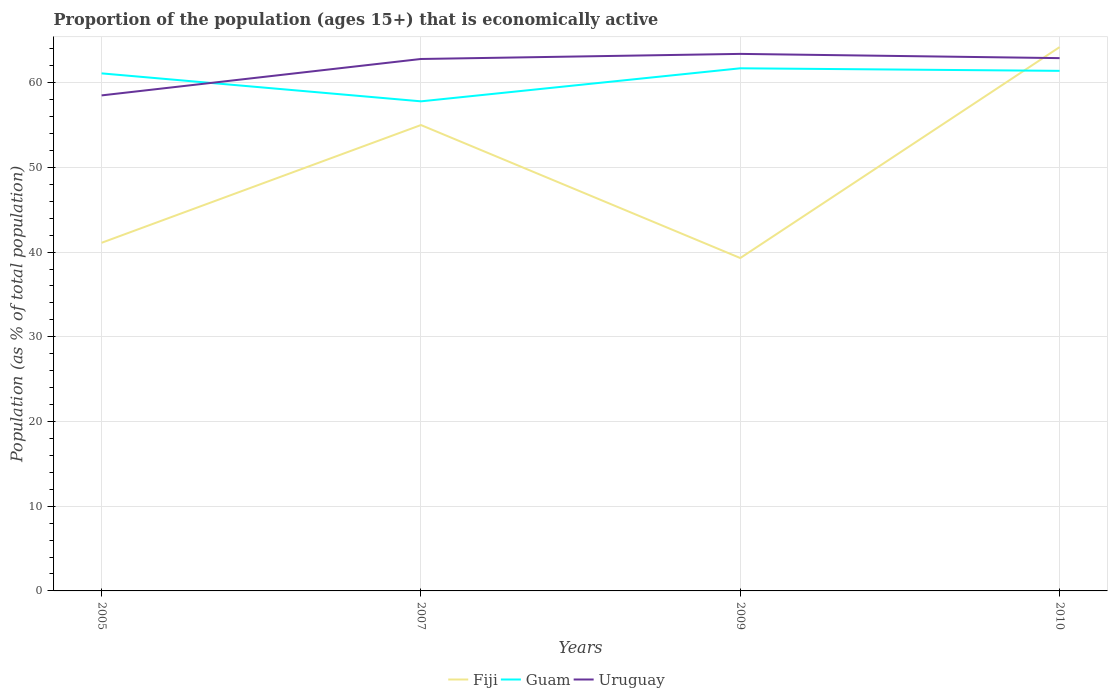Across all years, what is the maximum proportion of the population that is economically active in Fiji?
Give a very brief answer. 39.3. What is the total proportion of the population that is economically active in Uruguay in the graph?
Give a very brief answer. -0.1. What is the difference between the highest and the second highest proportion of the population that is economically active in Fiji?
Your answer should be very brief. 24.9. Are the values on the major ticks of Y-axis written in scientific E-notation?
Provide a short and direct response. No. Does the graph contain grids?
Your answer should be very brief. Yes. Where does the legend appear in the graph?
Keep it short and to the point. Bottom center. How many legend labels are there?
Provide a succinct answer. 3. What is the title of the graph?
Keep it short and to the point. Proportion of the population (ages 15+) that is economically active. Does "Guatemala" appear as one of the legend labels in the graph?
Give a very brief answer. No. What is the label or title of the Y-axis?
Give a very brief answer. Population (as % of total population). What is the Population (as % of total population) in Fiji in 2005?
Offer a terse response. 41.1. What is the Population (as % of total population) in Guam in 2005?
Make the answer very short. 61.1. What is the Population (as % of total population) in Uruguay in 2005?
Make the answer very short. 58.5. What is the Population (as % of total population) of Fiji in 2007?
Your answer should be compact. 55. What is the Population (as % of total population) of Guam in 2007?
Make the answer very short. 57.8. What is the Population (as % of total population) in Uruguay in 2007?
Your answer should be compact. 62.8. What is the Population (as % of total population) in Fiji in 2009?
Keep it short and to the point. 39.3. What is the Population (as % of total population) in Guam in 2009?
Offer a very short reply. 61.7. What is the Population (as % of total population) in Uruguay in 2009?
Ensure brevity in your answer.  63.4. What is the Population (as % of total population) in Fiji in 2010?
Provide a short and direct response. 64.2. What is the Population (as % of total population) of Guam in 2010?
Keep it short and to the point. 61.4. What is the Population (as % of total population) of Uruguay in 2010?
Give a very brief answer. 62.9. Across all years, what is the maximum Population (as % of total population) of Fiji?
Provide a succinct answer. 64.2. Across all years, what is the maximum Population (as % of total population) in Guam?
Offer a very short reply. 61.7. Across all years, what is the maximum Population (as % of total population) of Uruguay?
Keep it short and to the point. 63.4. Across all years, what is the minimum Population (as % of total population) of Fiji?
Your answer should be very brief. 39.3. Across all years, what is the minimum Population (as % of total population) of Guam?
Your response must be concise. 57.8. Across all years, what is the minimum Population (as % of total population) in Uruguay?
Offer a terse response. 58.5. What is the total Population (as % of total population) in Fiji in the graph?
Offer a terse response. 199.6. What is the total Population (as % of total population) in Guam in the graph?
Give a very brief answer. 242. What is the total Population (as % of total population) in Uruguay in the graph?
Make the answer very short. 247.6. What is the difference between the Population (as % of total population) in Uruguay in 2005 and that in 2007?
Give a very brief answer. -4.3. What is the difference between the Population (as % of total population) in Fiji in 2005 and that in 2009?
Make the answer very short. 1.8. What is the difference between the Population (as % of total population) of Uruguay in 2005 and that in 2009?
Offer a terse response. -4.9. What is the difference between the Population (as % of total population) in Fiji in 2005 and that in 2010?
Provide a short and direct response. -23.1. What is the difference between the Population (as % of total population) of Guam in 2005 and that in 2010?
Offer a terse response. -0.3. What is the difference between the Population (as % of total population) in Uruguay in 2005 and that in 2010?
Your answer should be compact. -4.4. What is the difference between the Population (as % of total population) in Fiji in 2007 and that in 2010?
Offer a terse response. -9.2. What is the difference between the Population (as % of total population) in Uruguay in 2007 and that in 2010?
Your answer should be very brief. -0.1. What is the difference between the Population (as % of total population) of Fiji in 2009 and that in 2010?
Your answer should be very brief. -24.9. What is the difference between the Population (as % of total population) in Guam in 2009 and that in 2010?
Offer a terse response. 0.3. What is the difference between the Population (as % of total population) in Uruguay in 2009 and that in 2010?
Your answer should be very brief. 0.5. What is the difference between the Population (as % of total population) in Fiji in 2005 and the Population (as % of total population) in Guam in 2007?
Your response must be concise. -16.7. What is the difference between the Population (as % of total population) in Fiji in 2005 and the Population (as % of total population) in Uruguay in 2007?
Your answer should be very brief. -21.7. What is the difference between the Population (as % of total population) in Fiji in 2005 and the Population (as % of total population) in Guam in 2009?
Make the answer very short. -20.6. What is the difference between the Population (as % of total population) of Fiji in 2005 and the Population (as % of total population) of Uruguay in 2009?
Offer a very short reply. -22.3. What is the difference between the Population (as % of total population) of Fiji in 2005 and the Population (as % of total population) of Guam in 2010?
Your answer should be very brief. -20.3. What is the difference between the Population (as % of total population) of Fiji in 2005 and the Population (as % of total population) of Uruguay in 2010?
Provide a succinct answer. -21.8. What is the difference between the Population (as % of total population) of Guam in 2005 and the Population (as % of total population) of Uruguay in 2010?
Provide a succinct answer. -1.8. What is the difference between the Population (as % of total population) in Fiji in 2007 and the Population (as % of total population) in Guam in 2009?
Your answer should be compact. -6.7. What is the difference between the Population (as % of total population) of Guam in 2007 and the Population (as % of total population) of Uruguay in 2009?
Make the answer very short. -5.6. What is the difference between the Population (as % of total population) in Fiji in 2007 and the Population (as % of total population) in Guam in 2010?
Provide a short and direct response. -6.4. What is the difference between the Population (as % of total population) in Fiji in 2007 and the Population (as % of total population) in Uruguay in 2010?
Provide a short and direct response. -7.9. What is the difference between the Population (as % of total population) in Fiji in 2009 and the Population (as % of total population) in Guam in 2010?
Your response must be concise. -22.1. What is the difference between the Population (as % of total population) in Fiji in 2009 and the Population (as % of total population) in Uruguay in 2010?
Give a very brief answer. -23.6. What is the average Population (as % of total population) in Fiji per year?
Your answer should be very brief. 49.9. What is the average Population (as % of total population) in Guam per year?
Give a very brief answer. 60.5. What is the average Population (as % of total population) in Uruguay per year?
Your answer should be compact. 61.9. In the year 2005, what is the difference between the Population (as % of total population) in Fiji and Population (as % of total population) in Uruguay?
Offer a terse response. -17.4. In the year 2005, what is the difference between the Population (as % of total population) in Guam and Population (as % of total population) in Uruguay?
Provide a succinct answer. 2.6. In the year 2007, what is the difference between the Population (as % of total population) in Fiji and Population (as % of total population) in Uruguay?
Your answer should be very brief. -7.8. In the year 2007, what is the difference between the Population (as % of total population) in Guam and Population (as % of total population) in Uruguay?
Offer a very short reply. -5. In the year 2009, what is the difference between the Population (as % of total population) of Fiji and Population (as % of total population) of Guam?
Offer a terse response. -22.4. In the year 2009, what is the difference between the Population (as % of total population) in Fiji and Population (as % of total population) in Uruguay?
Keep it short and to the point. -24.1. In the year 2009, what is the difference between the Population (as % of total population) of Guam and Population (as % of total population) of Uruguay?
Offer a very short reply. -1.7. In the year 2010, what is the difference between the Population (as % of total population) of Fiji and Population (as % of total population) of Guam?
Give a very brief answer. 2.8. In the year 2010, what is the difference between the Population (as % of total population) of Fiji and Population (as % of total population) of Uruguay?
Keep it short and to the point. 1.3. What is the ratio of the Population (as % of total population) in Fiji in 2005 to that in 2007?
Your answer should be very brief. 0.75. What is the ratio of the Population (as % of total population) of Guam in 2005 to that in 2007?
Your response must be concise. 1.06. What is the ratio of the Population (as % of total population) of Uruguay in 2005 to that in 2007?
Your answer should be very brief. 0.93. What is the ratio of the Population (as % of total population) in Fiji in 2005 to that in 2009?
Your answer should be very brief. 1.05. What is the ratio of the Population (as % of total population) of Guam in 2005 to that in 2009?
Offer a terse response. 0.99. What is the ratio of the Population (as % of total population) in Uruguay in 2005 to that in 2009?
Offer a terse response. 0.92. What is the ratio of the Population (as % of total population) in Fiji in 2005 to that in 2010?
Keep it short and to the point. 0.64. What is the ratio of the Population (as % of total population) of Fiji in 2007 to that in 2009?
Your answer should be very brief. 1.4. What is the ratio of the Population (as % of total population) of Guam in 2007 to that in 2009?
Ensure brevity in your answer.  0.94. What is the ratio of the Population (as % of total population) in Fiji in 2007 to that in 2010?
Your response must be concise. 0.86. What is the ratio of the Population (as % of total population) of Guam in 2007 to that in 2010?
Your response must be concise. 0.94. What is the ratio of the Population (as % of total population) of Fiji in 2009 to that in 2010?
Your answer should be very brief. 0.61. What is the ratio of the Population (as % of total population) of Uruguay in 2009 to that in 2010?
Your response must be concise. 1.01. What is the difference between the highest and the lowest Population (as % of total population) in Fiji?
Keep it short and to the point. 24.9. 